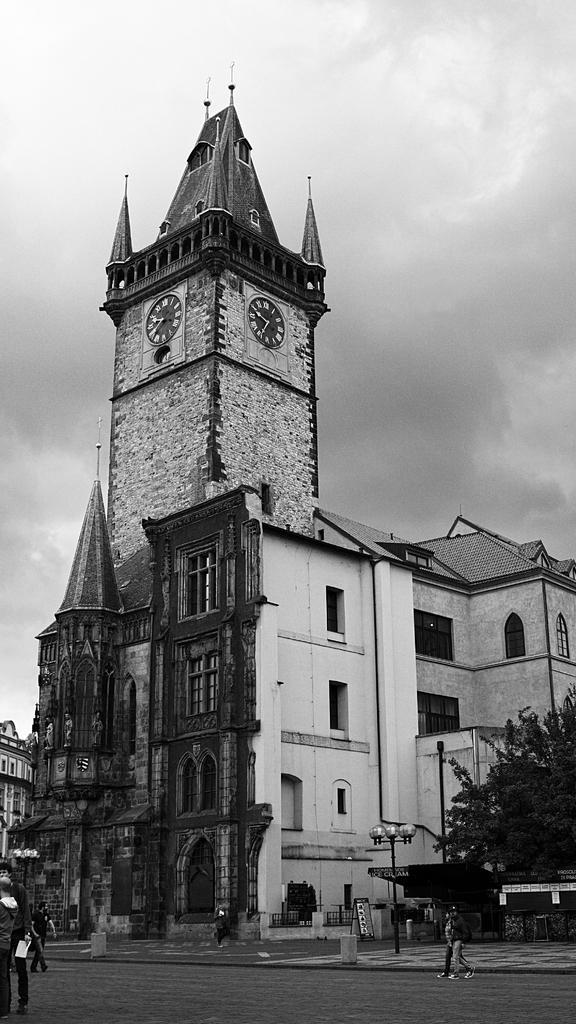How would you summarize this image in a sentence or two? This is black and white picture where we can see road, pole, tree and building. The sky is covered with clouds. 